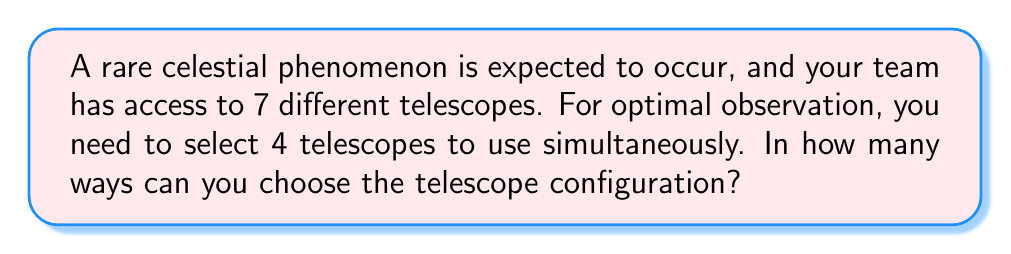Help me with this question. To solve this problem, we need to use the combination formula. We are selecting 4 telescopes out of 7, where the order doesn't matter (as we're using them simultaneously).

The formula for combinations is:

$$ C(n,r) = \binom{n}{r} = \frac{n!}{r!(n-r)!} $$

Where:
- $n$ is the total number of items to choose from (in this case, 7 telescopes)
- $r$ is the number of items being chosen (in this case, 4 telescopes)

Let's plug in our values:

$$ C(7,4) = \binom{7}{4} = \frac{7!}{4!(7-4)!} = \frac{7!}{4!3!} $$

Now, let's calculate this step-by-step:

1) $7! = 7 \times 6 \times 5 \times 4 \times 3 \times 2 \times 1 = 5040$
2) $4! = 4 \times 3 \times 2 \times 1 = 24$
3) $3! = 3 \times 2 \times 1 = 6$

Substituting these values:

$$ \frac{7!}{4!3!} = \frac{5040}{24 \times 6} = \frac{5040}{144} = 35 $$

Therefore, there are 35 possible ways to choose 4 telescopes out of 7 for the observation.
Answer: 35 